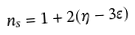<formula> <loc_0><loc_0><loc_500><loc_500>n _ { s } = 1 + 2 ( \eta - 3 \epsilon )</formula> 